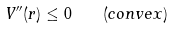<formula> <loc_0><loc_0><loc_500><loc_500>V ^ { \prime \prime } ( r ) \leq 0 \quad ( c o n v e x )</formula> 